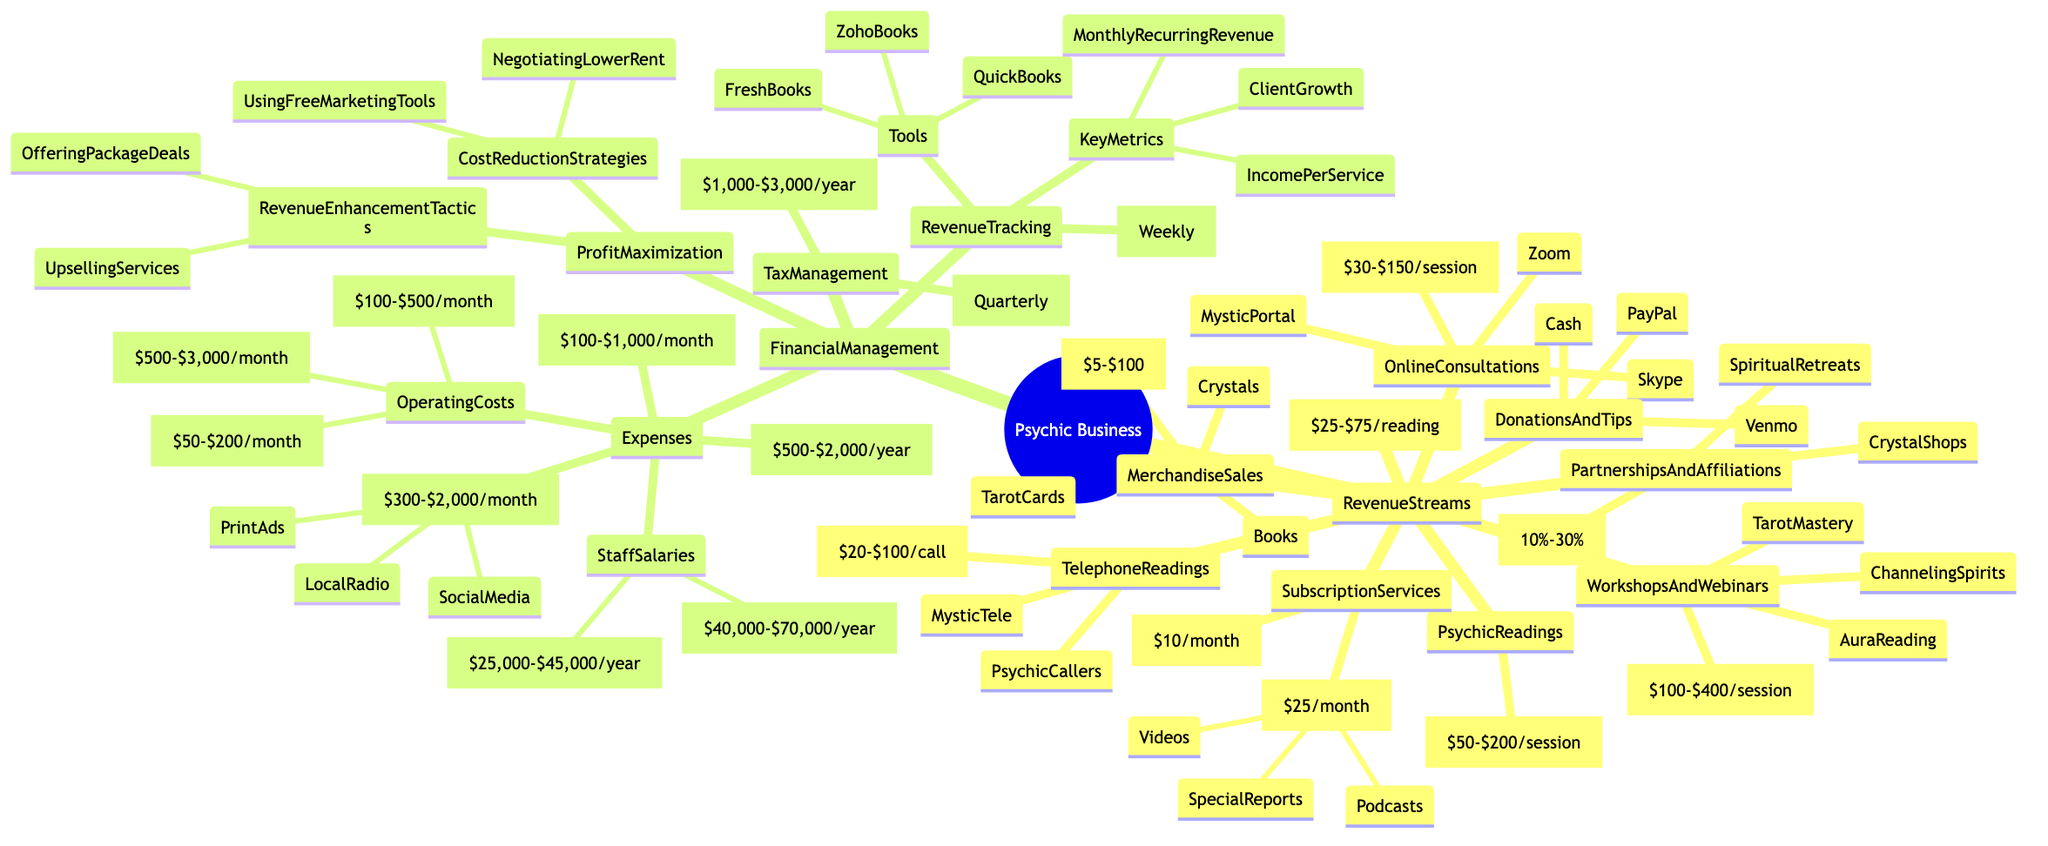What is the price range for in-person psychic readings? The diagram states that in-person psychic readings have a price range of $50 to $200 per session, which is directly listed under the "PsychicReadings" node.
Answer: $50 - $200 per session How many platforms are used for online consultations? The "OnlineConsultations" node lists three specific platforms: Zoom, Skype, and MysticPortal, thus counting them gives us the total number of platforms.
Answer: 3 What is the monthly budget for marketing and advertising? The "Expenses" section under "FinancialManagement" shows a range for marketing and advertising expenses between $300 and $2,000, clearly stated in the relevant node.
Answer: $300 - $2,000 What services are offered under SubscriptionServices? Within the "SubscriptionServices" node, two specific services are mentioned: Monthly Newsletter and Exclusive Content, indicating the offerings available.
Answer: Monthly Newsletter, Exclusive Content What is the annual cost for full-time psychics? In the "StaffSalaries" section, the description directly states that the annual cost for full-time psychics ranges from $40,000 to $70,000.
Answer: $40,000 - $70,000 What are two strategies for cost reduction? Under "ProfitMaximization," the node lists two specific strategies: "Negotiating Lower Rent" and "Using Free Marketing Tools," denoting common tactics for reducing costs.
Answer: Negotiating Lower Rent, Using Free Marketing Tools What is the frequency for revenue tracking? The "RevenueTracking" node explicitly mentions that revenue tracking occurs weekly, making it straightforward to identify how often this activity takes place.
Answer: Weekly Which payment methods are listed for donations and tips? The "DonationsAndTips" node mentions three payment methods: PayPal, Venmo, and Cash, allowing us to see all options available for contributions.
Answer: PayPal, Venmo, Cash What is the filing frequency for tax management? Within the "TaxManagement" section, it indicates that the tax filing frequency is quarterly, which is a specific detail regarding tax-related activities.
Answer: Quarterly 